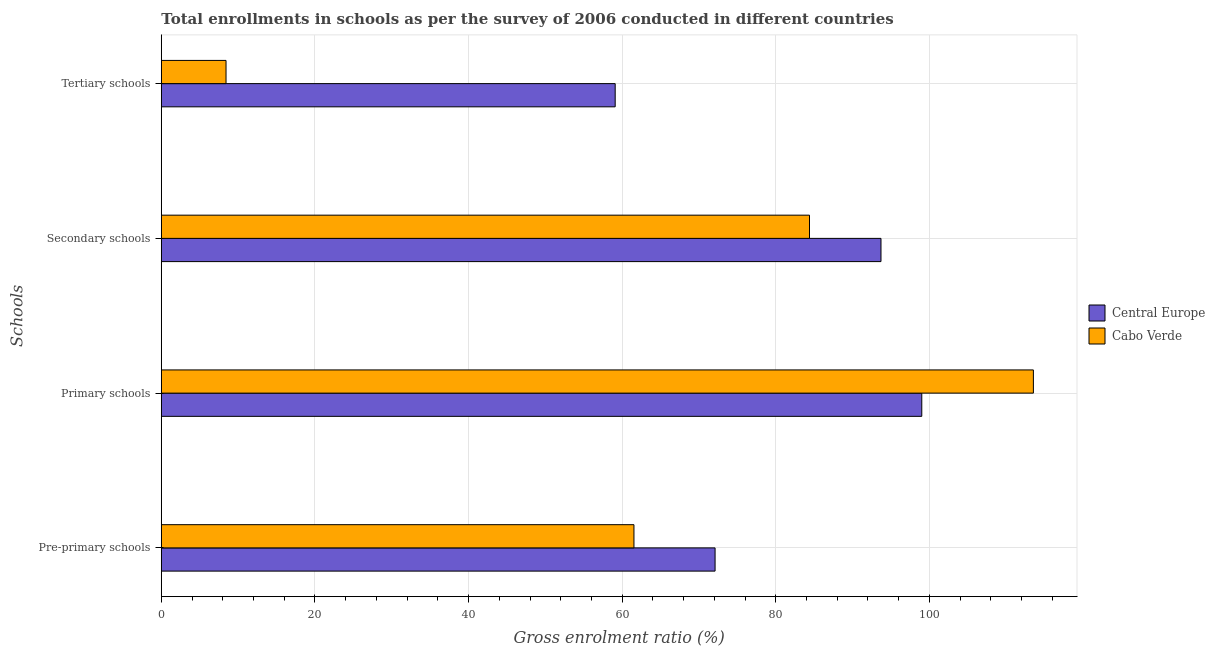How many different coloured bars are there?
Your response must be concise. 2. Are the number of bars on each tick of the Y-axis equal?
Your answer should be compact. Yes. How many bars are there on the 4th tick from the top?
Offer a terse response. 2. What is the label of the 3rd group of bars from the top?
Your response must be concise. Primary schools. What is the gross enrolment ratio in secondary schools in Central Europe?
Provide a short and direct response. 93.69. Across all countries, what is the maximum gross enrolment ratio in primary schools?
Keep it short and to the point. 113.53. Across all countries, what is the minimum gross enrolment ratio in tertiary schools?
Your answer should be very brief. 8.42. In which country was the gross enrolment ratio in primary schools maximum?
Offer a terse response. Cabo Verde. In which country was the gross enrolment ratio in pre-primary schools minimum?
Make the answer very short. Cabo Verde. What is the total gross enrolment ratio in pre-primary schools in the graph?
Give a very brief answer. 133.62. What is the difference between the gross enrolment ratio in pre-primary schools in Central Europe and that in Cabo Verde?
Make the answer very short. 10.56. What is the difference between the gross enrolment ratio in tertiary schools in Central Europe and the gross enrolment ratio in pre-primary schools in Cabo Verde?
Your answer should be compact. -2.44. What is the average gross enrolment ratio in tertiary schools per country?
Your response must be concise. 33.76. What is the difference between the gross enrolment ratio in tertiary schools and gross enrolment ratio in secondary schools in Cabo Verde?
Your answer should be compact. -75.96. What is the ratio of the gross enrolment ratio in tertiary schools in Cabo Verde to that in Central Europe?
Keep it short and to the point. 0.14. What is the difference between the highest and the second highest gross enrolment ratio in pre-primary schools?
Provide a short and direct response. 10.56. What is the difference between the highest and the lowest gross enrolment ratio in tertiary schools?
Provide a short and direct response. 50.66. Is the sum of the gross enrolment ratio in tertiary schools in Cabo Verde and Central Europe greater than the maximum gross enrolment ratio in primary schools across all countries?
Your answer should be compact. No. Is it the case that in every country, the sum of the gross enrolment ratio in pre-primary schools and gross enrolment ratio in secondary schools is greater than the sum of gross enrolment ratio in primary schools and gross enrolment ratio in tertiary schools?
Your answer should be very brief. No. What does the 2nd bar from the top in Tertiary schools represents?
Your answer should be compact. Central Europe. What does the 1st bar from the bottom in Secondary schools represents?
Your answer should be very brief. Central Europe. Is it the case that in every country, the sum of the gross enrolment ratio in pre-primary schools and gross enrolment ratio in primary schools is greater than the gross enrolment ratio in secondary schools?
Your response must be concise. Yes. How many bars are there?
Offer a terse response. 8. Are all the bars in the graph horizontal?
Keep it short and to the point. Yes. How many countries are there in the graph?
Your response must be concise. 2. What is the difference between two consecutive major ticks on the X-axis?
Give a very brief answer. 20. Are the values on the major ticks of X-axis written in scientific E-notation?
Your answer should be compact. No. Does the graph contain grids?
Keep it short and to the point. Yes. How many legend labels are there?
Provide a succinct answer. 2. What is the title of the graph?
Offer a terse response. Total enrollments in schools as per the survey of 2006 conducted in different countries. What is the label or title of the X-axis?
Give a very brief answer. Gross enrolment ratio (%). What is the label or title of the Y-axis?
Keep it short and to the point. Schools. What is the Gross enrolment ratio (%) in Central Europe in Pre-primary schools?
Offer a terse response. 72.09. What is the Gross enrolment ratio (%) of Cabo Verde in Pre-primary schools?
Offer a very short reply. 61.53. What is the Gross enrolment ratio (%) in Central Europe in Primary schools?
Keep it short and to the point. 99. What is the Gross enrolment ratio (%) in Cabo Verde in Primary schools?
Keep it short and to the point. 113.53. What is the Gross enrolment ratio (%) in Central Europe in Secondary schools?
Offer a terse response. 93.69. What is the Gross enrolment ratio (%) in Cabo Verde in Secondary schools?
Your answer should be compact. 84.38. What is the Gross enrolment ratio (%) of Central Europe in Tertiary schools?
Your response must be concise. 59.09. What is the Gross enrolment ratio (%) of Cabo Verde in Tertiary schools?
Keep it short and to the point. 8.42. Across all Schools, what is the maximum Gross enrolment ratio (%) of Central Europe?
Your answer should be very brief. 99. Across all Schools, what is the maximum Gross enrolment ratio (%) of Cabo Verde?
Make the answer very short. 113.53. Across all Schools, what is the minimum Gross enrolment ratio (%) of Central Europe?
Offer a very short reply. 59.09. Across all Schools, what is the minimum Gross enrolment ratio (%) of Cabo Verde?
Your answer should be compact. 8.42. What is the total Gross enrolment ratio (%) in Central Europe in the graph?
Your response must be concise. 323.88. What is the total Gross enrolment ratio (%) of Cabo Verde in the graph?
Make the answer very short. 267.87. What is the difference between the Gross enrolment ratio (%) of Central Europe in Pre-primary schools and that in Primary schools?
Provide a short and direct response. -26.91. What is the difference between the Gross enrolment ratio (%) of Cabo Verde in Pre-primary schools and that in Primary schools?
Offer a very short reply. -52. What is the difference between the Gross enrolment ratio (%) of Central Europe in Pre-primary schools and that in Secondary schools?
Give a very brief answer. -21.6. What is the difference between the Gross enrolment ratio (%) in Cabo Verde in Pre-primary schools and that in Secondary schools?
Keep it short and to the point. -22.85. What is the difference between the Gross enrolment ratio (%) in Central Europe in Pre-primary schools and that in Tertiary schools?
Offer a very short reply. 13.01. What is the difference between the Gross enrolment ratio (%) of Cabo Verde in Pre-primary schools and that in Tertiary schools?
Make the answer very short. 53.11. What is the difference between the Gross enrolment ratio (%) in Central Europe in Primary schools and that in Secondary schools?
Offer a terse response. 5.31. What is the difference between the Gross enrolment ratio (%) in Cabo Verde in Primary schools and that in Secondary schools?
Your answer should be compact. 29.15. What is the difference between the Gross enrolment ratio (%) in Central Europe in Primary schools and that in Tertiary schools?
Make the answer very short. 39.91. What is the difference between the Gross enrolment ratio (%) of Cabo Verde in Primary schools and that in Tertiary schools?
Your response must be concise. 105.11. What is the difference between the Gross enrolment ratio (%) of Central Europe in Secondary schools and that in Tertiary schools?
Make the answer very short. 34.6. What is the difference between the Gross enrolment ratio (%) in Cabo Verde in Secondary schools and that in Tertiary schools?
Offer a terse response. 75.96. What is the difference between the Gross enrolment ratio (%) of Central Europe in Pre-primary schools and the Gross enrolment ratio (%) of Cabo Verde in Primary schools?
Your response must be concise. -41.44. What is the difference between the Gross enrolment ratio (%) in Central Europe in Pre-primary schools and the Gross enrolment ratio (%) in Cabo Verde in Secondary schools?
Make the answer very short. -12.29. What is the difference between the Gross enrolment ratio (%) of Central Europe in Pre-primary schools and the Gross enrolment ratio (%) of Cabo Verde in Tertiary schools?
Your response must be concise. 63.67. What is the difference between the Gross enrolment ratio (%) in Central Europe in Primary schools and the Gross enrolment ratio (%) in Cabo Verde in Secondary schools?
Provide a short and direct response. 14.62. What is the difference between the Gross enrolment ratio (%) in Central Europe in Primary schools and the Gross enrolment ratio (%) in Cabo Verde in Tertiary schools?
Your answer should be compact. 90.58. What is the difference between the Gross enrolment ratio (%) of Central Europe in Secondary schools and the Gross enrolment ratio (%) of Cabo Verde in Tertiary schools?
Give a very brief answer. 85.27. What is the average Gross enrolment ratio (%) in Central Europe per Schools?
Your answer should be very brief. 80.97. What is the average Gross enrolment ratio (%) of Cabo Verde per Schools?
Provide a succinct answer. 66.97. What is the difference between the Gross enrolment ratio (%) of Central Europe and Gross enrolment ratio (%) of Cabo Verde in Pre-primary schools?
Ensure brevity in your answer.  10.56. What is the difference between the Gross enrolment ratio (%) of Central Europe and Gross enrolment ratio (%) of Cabo Verde in Primary schools?
Provide a short and direct response. -14.53. What is the difference between the Gross enrolment ratio (%) in Central Europe and Gross enrolment ratio (%) in Cabo Verde in Secondary schools?
Your response must be concise. 9.31. What is the difference between the Gross enrolment ratio (%) in Central Europe and Gross enrolment ratio (%) in Cabo Verde in Tertiary schools?
Offer a very short reply. 50.66. What is the ratio of the Gross enrolment ratio (%) of Central Europe in Pre-primary schools to that in Primary schools?
Provide a succinct answer. 0.73. What is the ratio of the Gross enrolment ratio (%) in Cabo Verde in Pre-primary schools to that in Primary schools?
Your response must be concise. 0.54. What is the ratio of the Gross enrolment ratio (%) of Central Europe in Pre-primary schools to that in Secondary schools?
Your answer should be very brief. 0.77. What is the ratio of the Gross enrolment ratio (%) of Cabo Verde in Pre-primary schools to that in Secondary schools?
Give a very brief answer. 0.73. What is the ratio of the Gross enrolment ratio (%) of Central Europe in Pre-primary schools to that in Tertiary schools?
Your answer should be very brief. 1.22. What is the ratio of the Gross enrolment ratio (%) in Cabo Verde in Pre-primary schools to that in Tertiary schools?
Give a very brief answer. 7.3. What is the ratio of the Gross enrolment ratio (%) in Central Europe in Primary schools to that in Secondary schools?
Provide a succinct answer. 1.06. What is the ratio of the Gross enrolment ratio (%) in Cabo Verde in Primary schools to that in Secondary schools?
Offer a very short reply. 1.35. What is the ratio of the Gross enrolment ratio (%) of Central Europe in Primary schools to that in Tertiary schools?
Ensure brevity in your answer.  1.68. What is the ratio of the Gross enrolment ratio (%) in Cabo Verde in Primary schools to that in Tertiary schools?
Provide a succinct answer. 13.48. What is the ratio of the Gross enrolment ratio (%) in Central Europe in Secondary schools to that in Tertiary schools?
Your response must be concise. 1.59. What is the ratio of the Gross enrolment ratio (%) in Cabo Verde in Secondary schools to that in Tertiary schools?
Keep it short and to the point. 10.02. What is the difference between the highest and the second highest Gross enrolment ratio (%) of Central Europe?
Your response must be concise. 5.31. What is the difference between the highest and the second highest Gross enrolment ratio (%) of Cabo Verde?
Offer a very short reply. 29.15. What is the difference between the highest and the lowest Gross enrolment ratio (%) of Central Europe?
Offer a very short reply. 39.91. What is the difference between the highest and the lowest Gross enrolment ratio (%) in Cabo Verde?
Your answer should be compact. 105.11. 